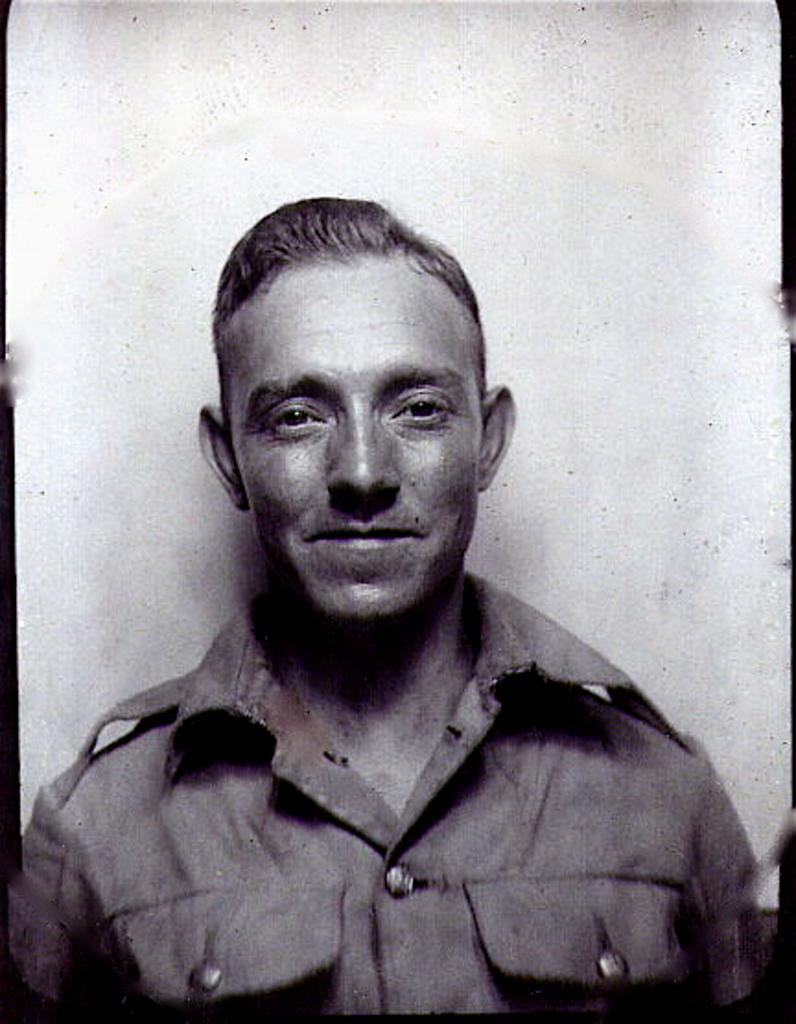What type of image is this? The image is a black and white photography. Who is in the photograph? There is a man in the photograph. Where is the man positioned in the image? The man is standing in the front. What is the man doing in the photograph? The man is smiling and giving a pose. What is the background of the photograph? There is a white background in the photograph. What type of car can be seen in the background of the photograph? There is no car visible in the background of the photograph; it has a white background. 